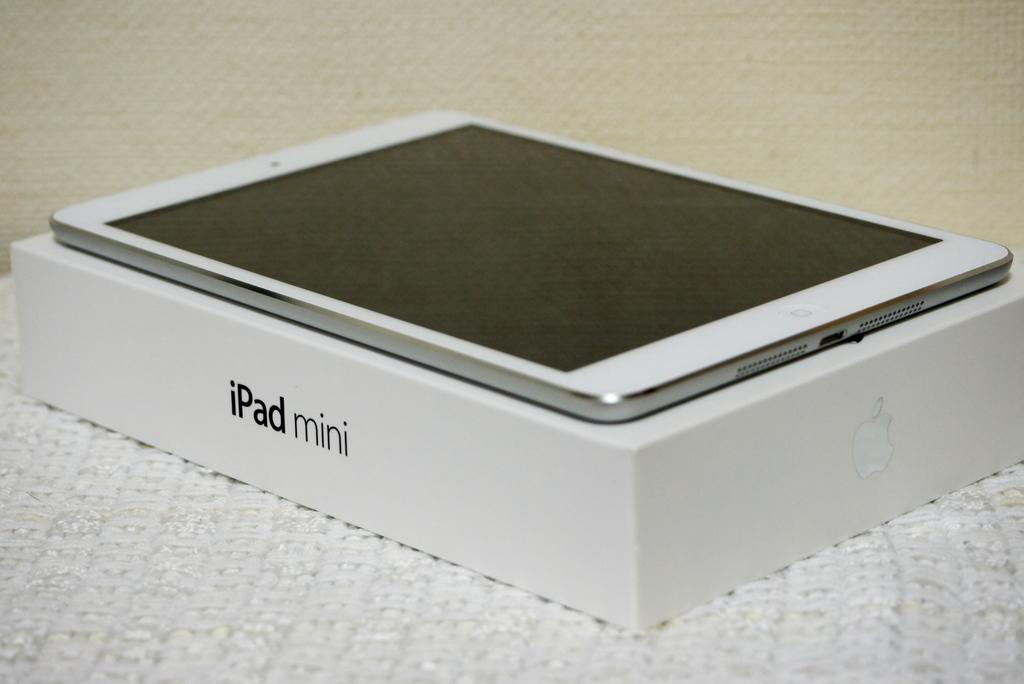<image>
Describe the image concisely. a iPad Mini on top of its box on a white rug 